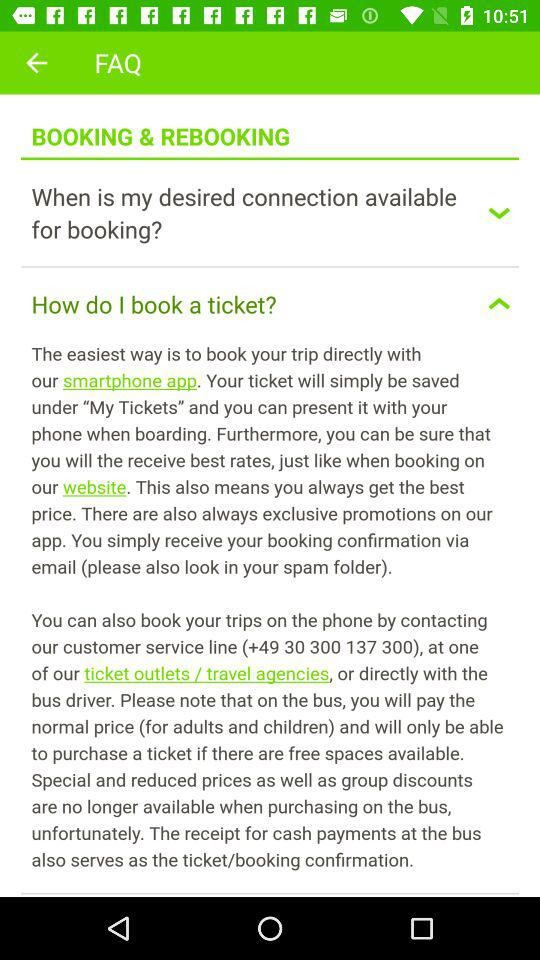Is "BOOKING & REBOOKING" checked or unchecked?
When the provided information is insufficient, respond with <no answer>. <no answer> 